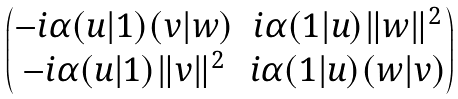<formula> <loc_0><loc_0><loc_500><loc_500>\begin{pmatrix} - i \alpha ( u | 1 ) ( v | w ) & i \alpha ( 1 | u ) \| w \| ^ { 2 } \\ - i \alpha ( u | 1 ) \| v \| ^ { 2 } & i \alpha ( 1 | u ) ( w | v ) \end{pmatrix}</formula> 